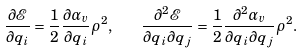<formula> <loc_0><loc_0><loc_500><loc_500>\frac { \partial \mathcal { E } } { \partial q _ { i } } = \frac { 1 } { 2 } \frac { \partial \alpha _ { v } } { \partial q _ { i } } \rho ^ { 2 } , \quad \frac { \partial ^ { 2 } \mathcal { E } } { \partial q _ { i } \partial q _ { j } } = \frac { 1 } { 2 } \frac { \partial ^ { 2 } \alpha _ { v } } { \partial q _ { i } \partial q _ { j } } \rho ^ { 2 } .</formula> 